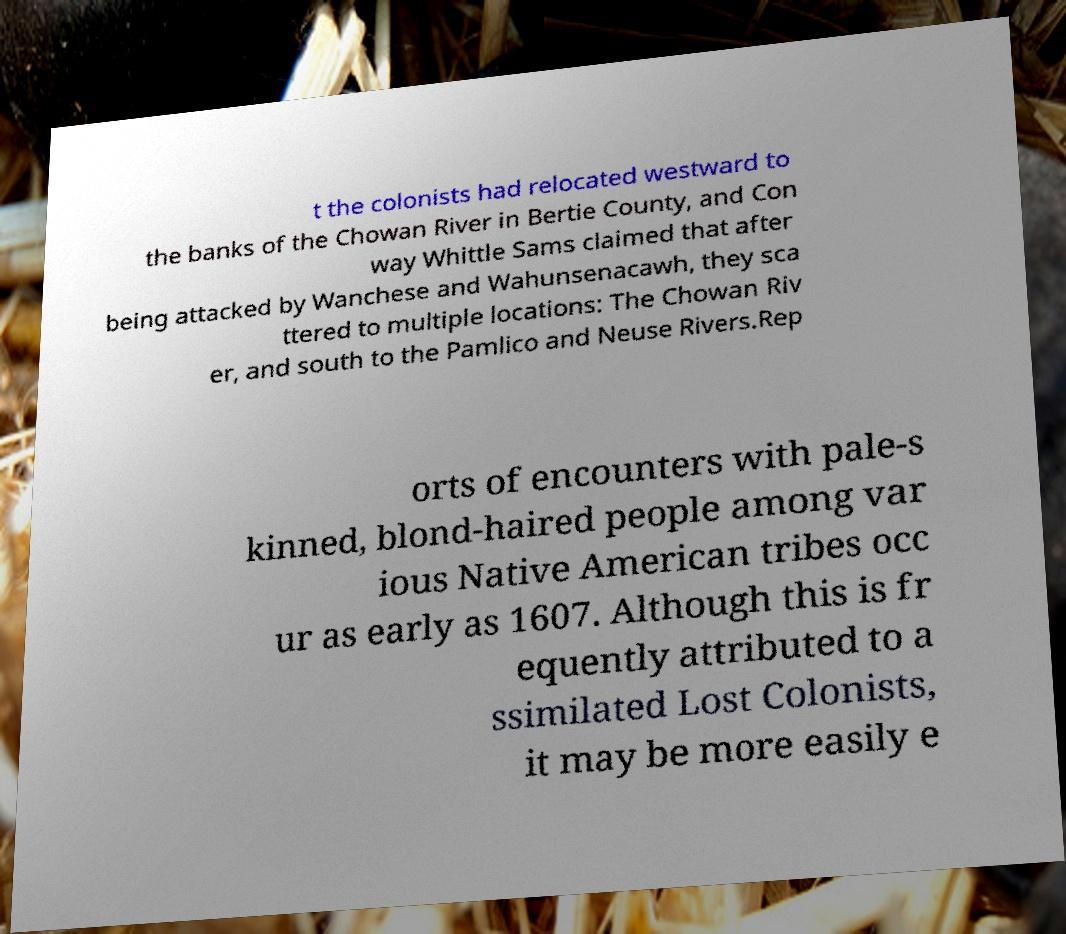For documentation purposes, I need the text within this image transcribed. Could you provide that? t the colonists had relocated westward to the banks of the Chowan River in Bertie County, and Con way Whittle Sams claimed that after being attacked by Wanchese and Wahunsenacawh, they sca ttered to multiple locations: The Chowan Riv er, and south to the Pamlico and Neuse Rivers.Rep orts of encounters with pale-s kinned, blond-haired people among var ious Native American tribes occ ur as early as 1607. Although this is fr equently attributed to a ssimilated Lost Colonists, it may be more easily e 